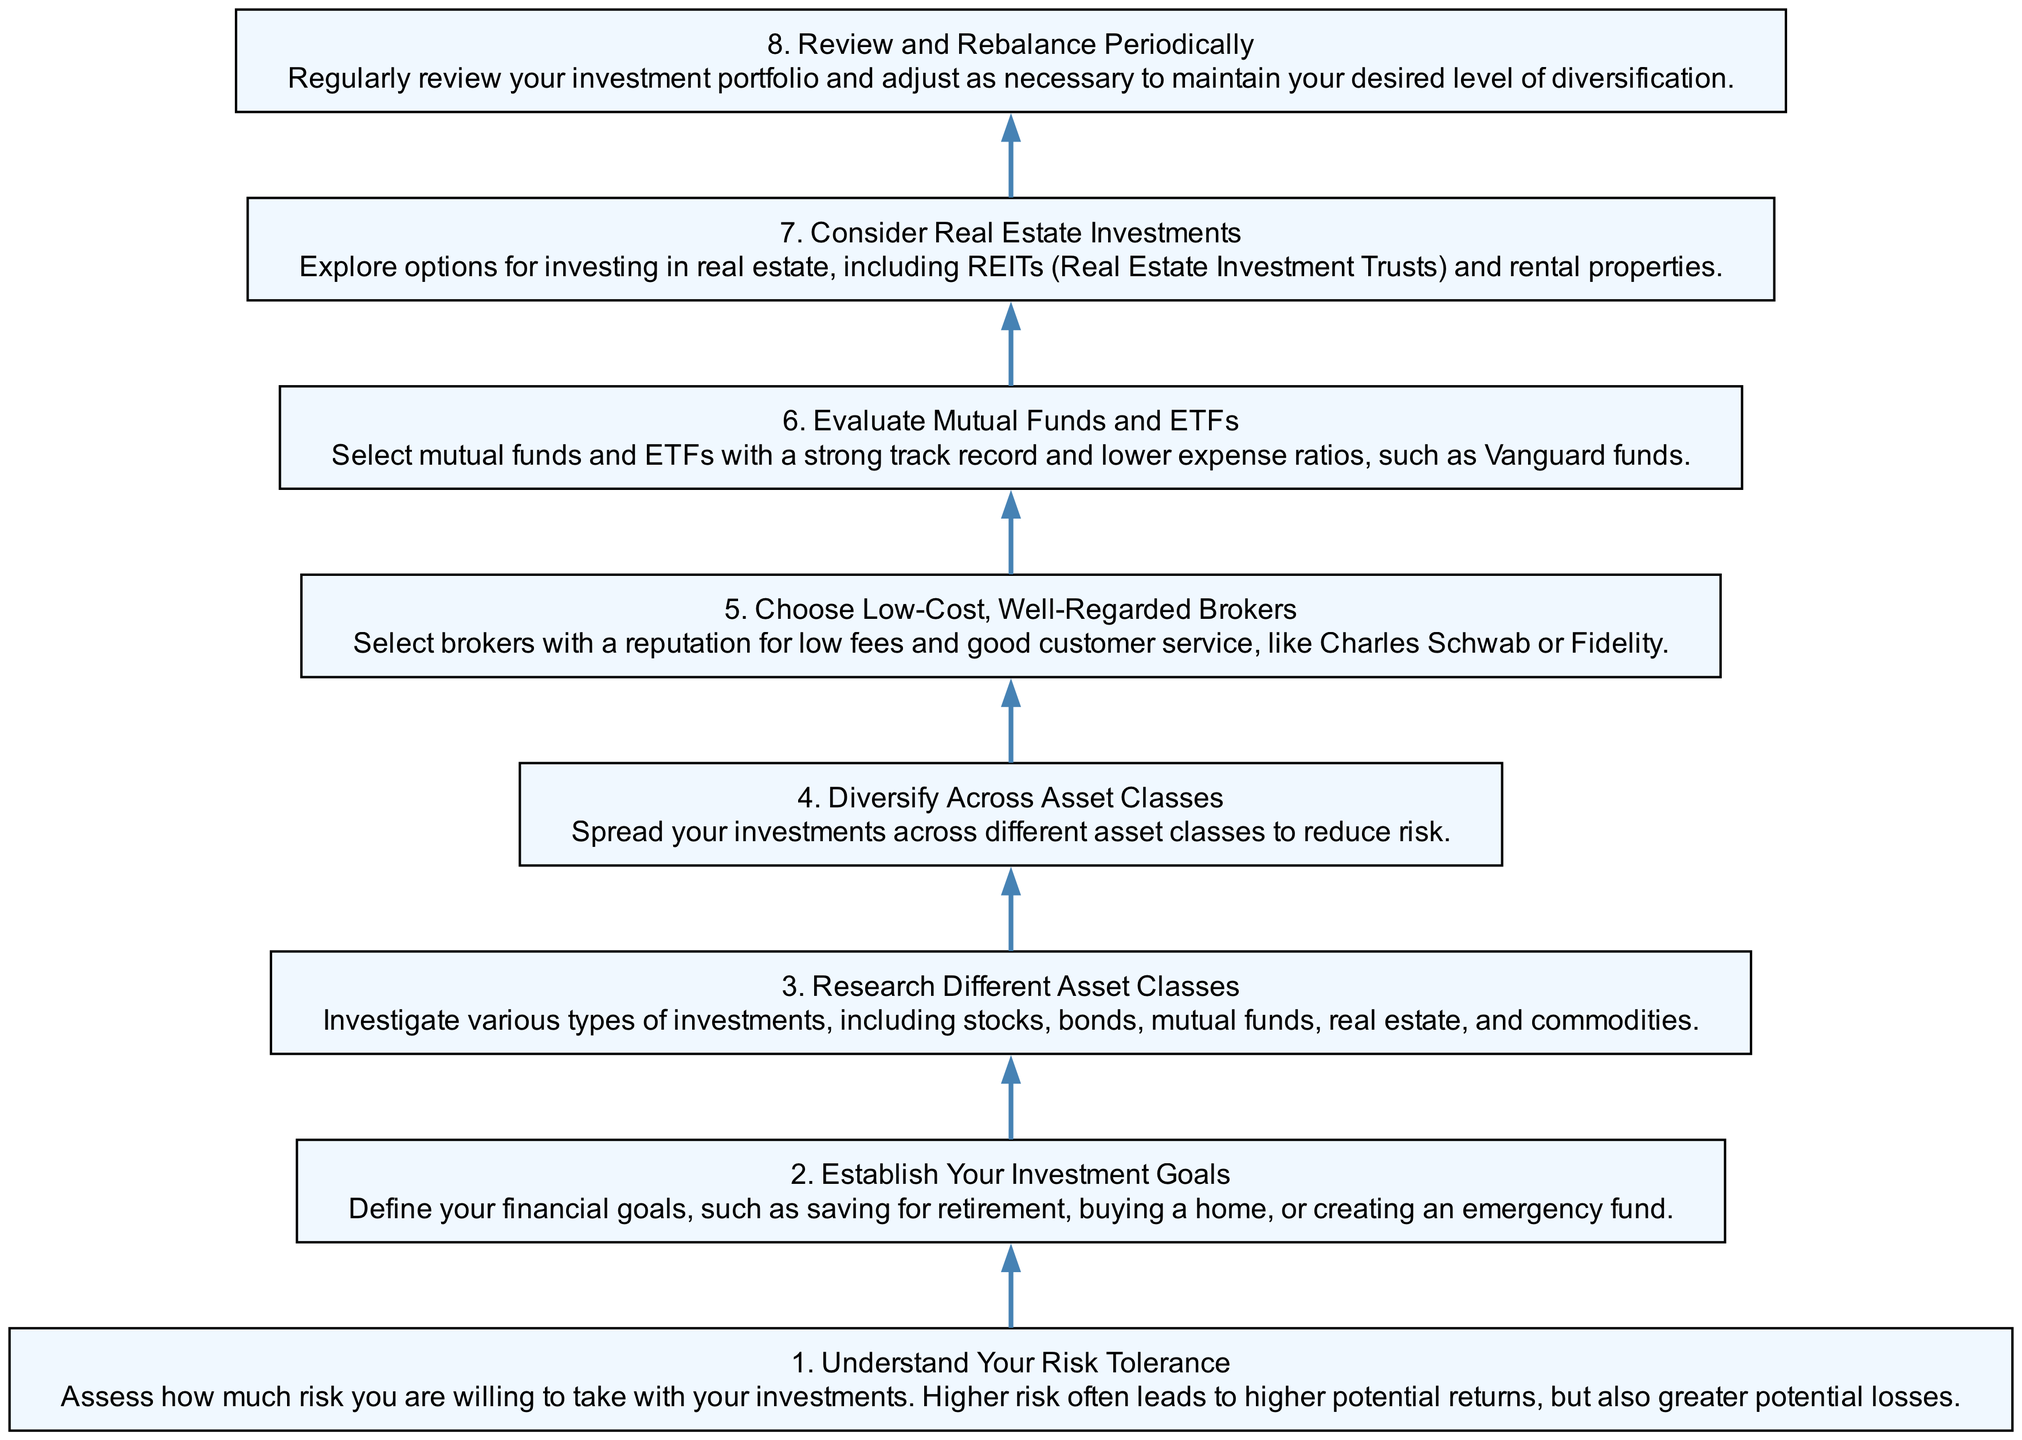What is the first step in diversifying financial investments? The diagram indicates that the first step is to "Understand Your Risk Tolerance," which is numbered as step 1.
Answer: Understand Your Risk Tolerance How many steps are there in the process? By counting the listed steps in the diagram from 1 to 8, we determine there are a total of 8 steps.
Answer: 8 What is the relationship between "Evaluate Mutual Funds and ETFs" and "Choose Low-Cost, Well-Regarded Brokers"? The diagram shows that "Choose Low-Cost, Well-Regarded Brokers" precedes "Evaluate Mutual Funds and ETFs," indicating that choosing brokers is an earlier step before evaluating funds.
Answer: Step 5 precedes Step 6 What are the two types of investments mentioned alongside real estate? In the step titled "Consider Real Estate Investments," it lists "REITs (Real Estate Investment Trusts)" and "rental properties" as options.
Answer: REITs and rental properties What is the last step in the investment diversification process? The final step shown in the diagram is "Review and Rebalance Periodically," which is numbered as step 8.
Answer: Review and Rebalance Periodically What should you do after establishing your investment goals? According to the flow chart, after defining your investment goals (step 2), the next action is to "Research Different Asset Classes" (step 3).
Answer: Research Different Asset Classes How can you reduce risk in your investment portfolio? The diagram states that diversifying your investments across different asset classes is a method to reduce risk as indicated in step 4.
Answer: Diversify Across Asset Classes Explain the process after "Research Different Asset Classes." After researching asset classes (step 3), the next step is to diversify across these asset classes (step 4), which promotes lower risk.
Answer: Diversify Across Asset Classes 